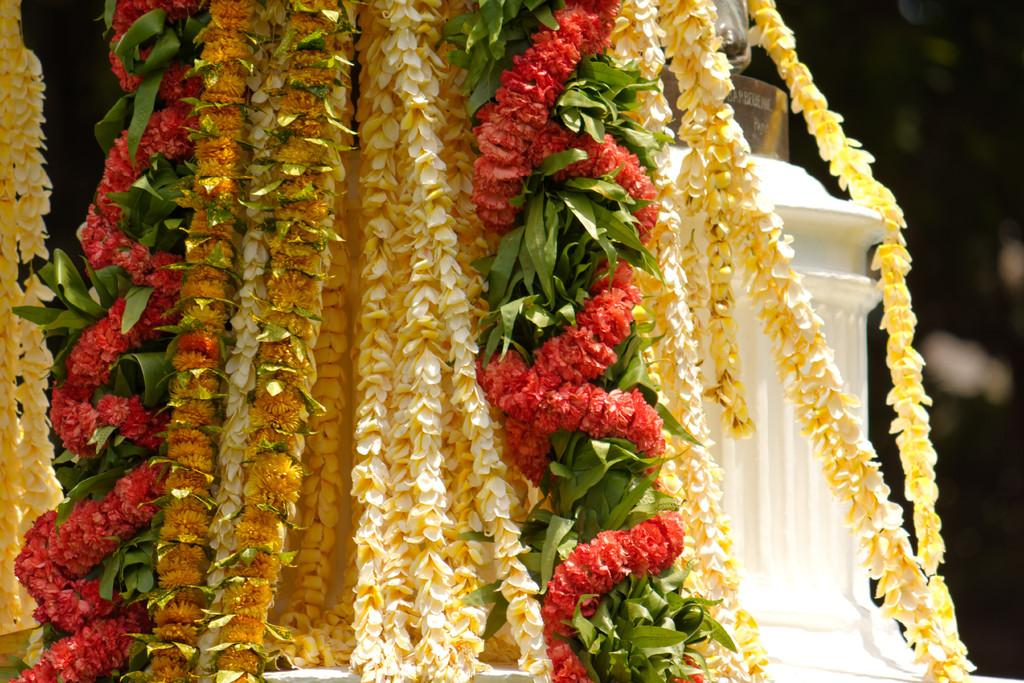What type of decorations are present in the image? There are colorful garlands in the image. Can you describe the white object on the right side of the image? Unfortunately, the facts provided do not give any details about the white object on the right side of the image. What type of butter is being used to hear the party in the image? There is no butter or party present in the image, so it is not possible to answer that question. 